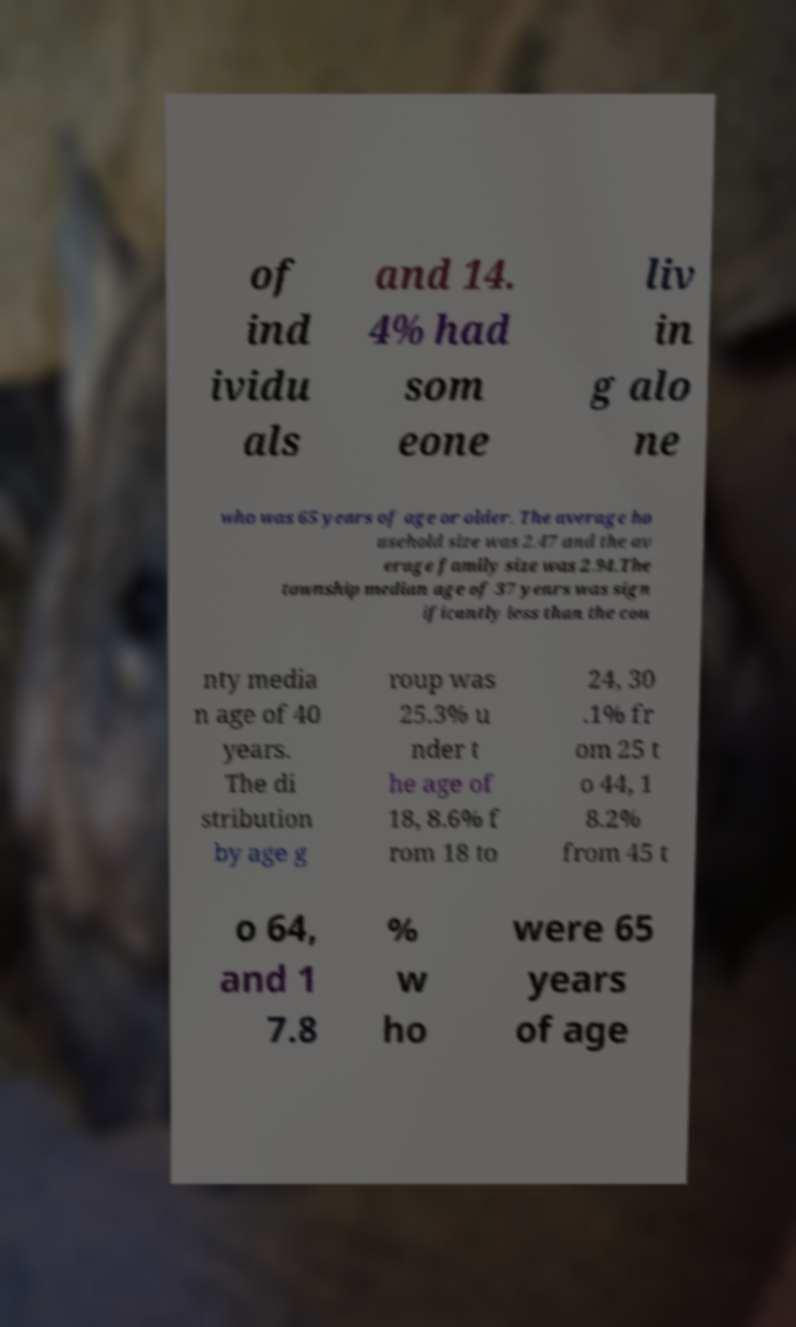Can you accurately transcribe the text from the provided image for me? of ind ividu als and 14. 4% had som eone liv in g alo ne who was 65 years of age or older. The average ho usehold size was 2.47 and the av erage family size was 2.94.The township median age of 37 years was sign ificantly less than the cou nty media n age of 40 years. The di stribution by age g roup was 25.3% u nder t he age of 18, 8.6% f rom 18 to 24, 30 .1% fr om 25 t o 44, 1 8.2% from 45 t o 64, and 1 7.8 % w ho were 65 years of age 